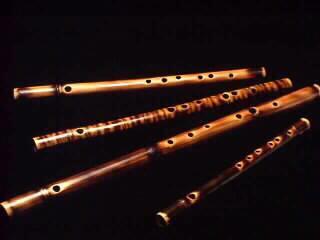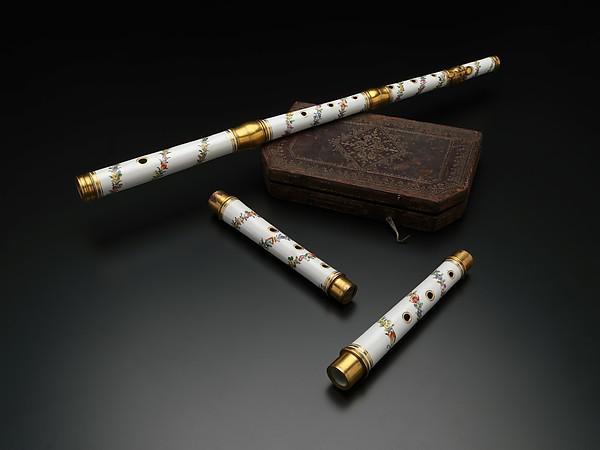The first image is the image on the left, the second image is the image on the right. Considering the images on both sides, is "One image shows at least four flutes arranged in a row but not perfectly parallel to one another." valid? Answer yes or no. Yes. The first image is the image on the left, the second image is the image on the right. For the images shown, is this caption "There are more than three instruments in at least one of the images." true? Answer yes or no. Yes. 